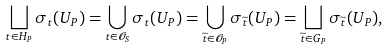Convert formula to latex. <formula><loc_0><loc_0><loc_500><loc_500>\bigsqcup _ { t \in H _ { P } } \sigma _ { t } ( U _ { P } ) = \bigcup _ { t \in \mathcal { O } _ { S } } \sigma _ { t } ( U _ { P } ) = \bigcup _ { \widetilde { t } \in \mathcal { O } _ { P } } \sigma _ { \widetilde { t } } ( U _ { P } ) = \bigsqcup _ { \widetilde { t } \in G _ { P } } \sigma _ { \widetilde { t } } ( U _ { P } ) ,</formula> 